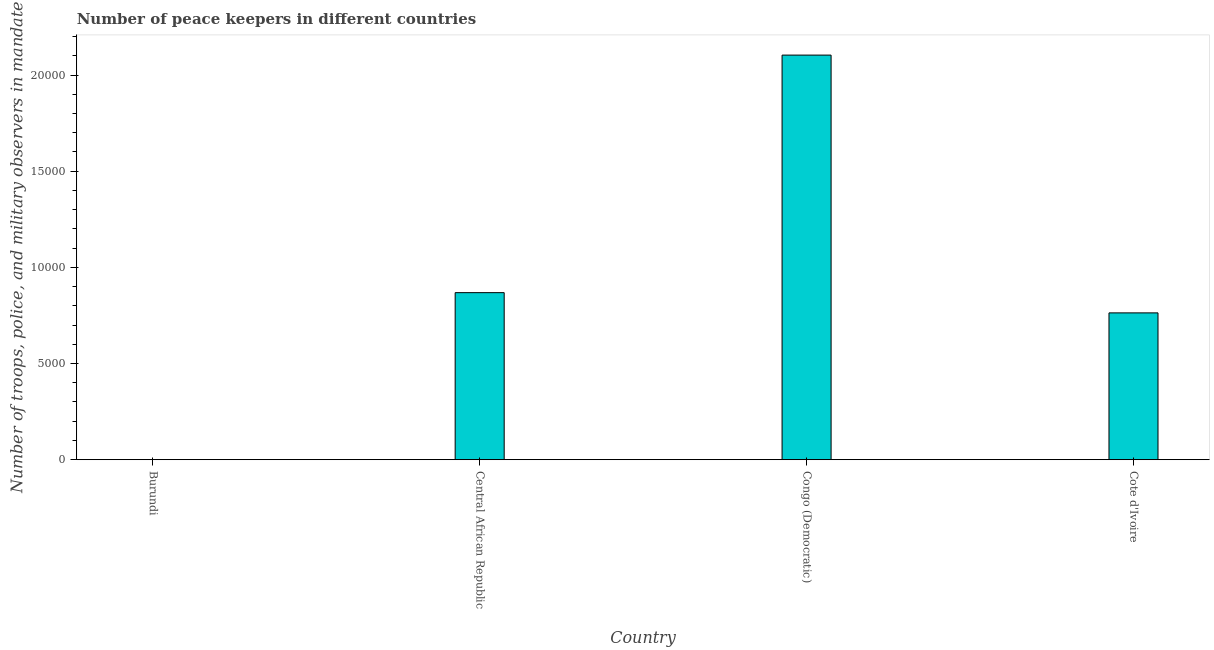What is the title of the graph?
Provide a short and direct response. Number of peace keepers in different countries. What is the label or title of the X-axis?
Your answer should be very brief. Country. What is the label or title of the Y-axis?
Offer a terse response. Number of troops, police, and military observers in mandate. What is the number of peace keepers in Burundi?
Give a very brief answer. 2. Across all countries, what is the maximum number of peace keepers?
Give a very brief answer. 2.10e+04. Across all countries, what is the minimum number of peace keepers?
Your answer should be very brief. 2. In which country was the number of peace keepers maximum?
Your answer should be very brief. Congo (Democratic). In which country was the number of peace keepers minimum?
Your answer should be compact. Burundi. What is the sum of the number of peace keepers?
Offer a very short reply. 3.74e+04. What is the difference between the number of peace keepers in Central African Republic and Congo (Democratic)?
Provide a succinct answer. -1.24e+04. What is the average number of peace keepers per country?
Offer a very short reply. 9339. What is the median number of peace keepers?
Offer a very short reply. 8159. What is the ratio of the number of peace keepers in Central African Republic to that in Cote d'Ivoire?
Provide a succinct answer. 1.14. Is the difference between the number of peace keepers in Burundi and Congo (Democratic) greater than the difference between any two countries?
Your answer should be compact. Yes. What is the difference between the highest and the second highest number of peace keepers?
Your answer should be compact. 1.24e+04. Is the sum of the number of peace keepers in Central African Republic and Cote d'Ivoire greater than the maximum number of peace keepers across all countries?
Offer a very short reply. No. What is the difference between the highest and the lowest number of peace keepers?
Offer a very short reply. 2.10e+04. How many bars are there?
Offer a terse response. 4. Are the values on the major ticks of Y-axis written in scientific E-notation?
Make the answer very short. No. What is the Number of troops, police, and military observers in mandate in Central African Republic?
Offer a terse response. 8685. What is the Number of troops, police, and military observers in mandate in Congo (Democratic)?
Your answer should be very brief. 2.10e+04. What is the Number of troops, police, and military observers in mandate in Cote d'Ivoire?
Offer a very short reply. 7633. What is the difference between the Number of troops, police, and military observers in mandate in Burundi and Central African Republic?
Provide a succinct answer. -8683. What is the difference between the Number of troops, police, and military observers in mandate in Burundi and Congo (Democratic)?
Make the answer very short. -2.10e+04. What is the difference between the Number of troops, police, and military observers in mandate in Burundi and Cote d'Ivoire?
Make the answer very short. -7631. What is the difference between the Number of troops, police, and military observers in mandate in Central African Republic and Congo (Democratic)?
Your answer should be very brief. -1.24e+04. What is the difference between the Number of troops, police, and military observers in mandate in Central African Republic and Cote d'Ivoire?
Your response must be concise. 1052. What is the difference between the Number of troops, police, and military observers in mandate in Congo (Democratic) and Cote d'Ivoire?
Your response must be concise. 1.34e+04. What is the ratio of the Number of troops, police, and military observers in mandate in Burundi to that in Central African Republic?
Give a very brief answer. 0. What is the ratio of the Number of troops, police, and military observers in mandate in Burundi to that in Cote d'Ivoire?
Give a very brief answer. 0. What is the ratio of the Number of troops, police, and military observers in mandate in Central African Republic to that in Congo (Democratic)?
Provide a succinct answer. 0.41. What is the ratio of the Number of troops, police, and military observers in mandate in Central African Republic to that in Cote d'Ivoire?
Keep it short and to the point. 1.14. What is the ratio of the Number of troops, police, and military observers in mandate in Congo (Democratic) to that in Cote d'Ivoire?
Your answer should be compact. 2.76. 